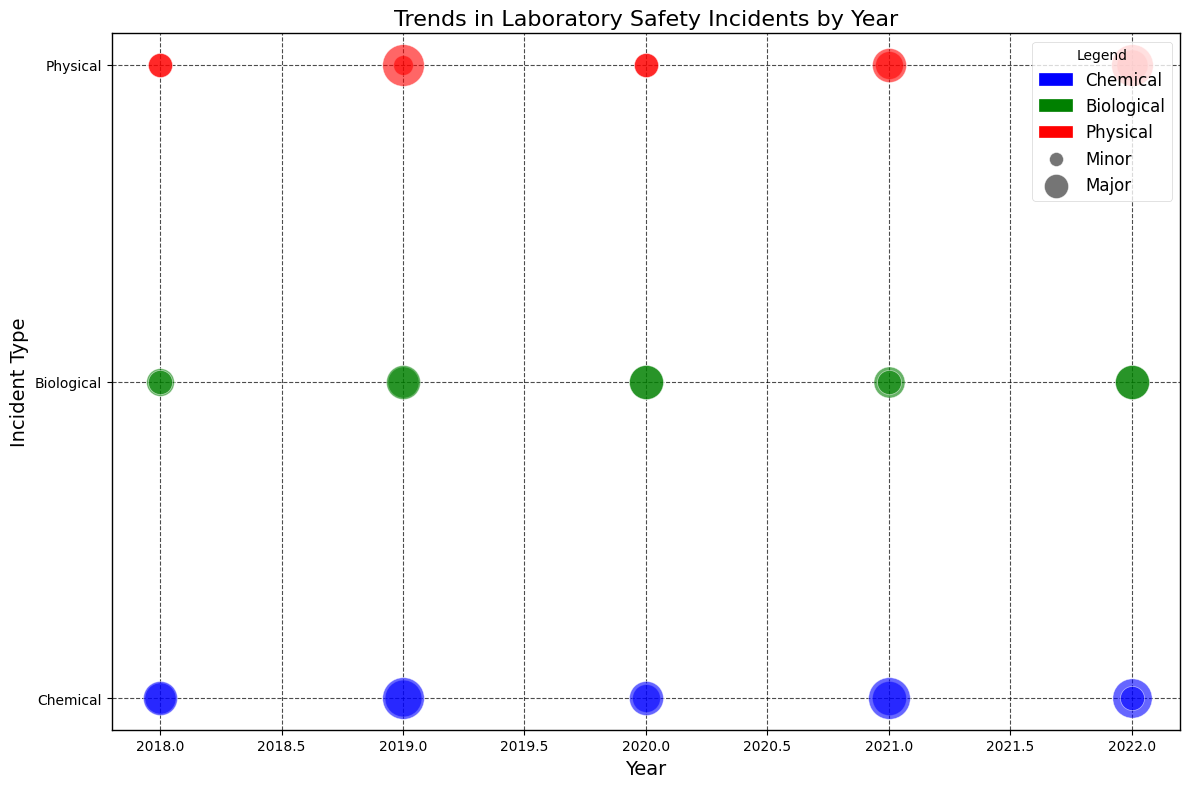What's the overall trend in the number of chemical incidents from 2018 to 2022? Observe the bubble sizes for Chemical incidents over the years. The counts show an increasing trend with minor fluctuations, rising from 7 in 2018, peaking at 9 in 2022.
Answer: Increasing Which year had the highest number of major physical incidents? Look for the largest bubbles labeled as Major under Physical incidents. The largest appears in 2019 and 2022, both with a count of 3.
Answer: 2019 and 2022 How did the number of biological minor incidents change from 2018 to 2022? Compare the bubble sizes for Biological Minor incidents across the years. It started with 4 in 2018, then increases to 5 in 2019, 6 in 2020, 5 in 2021, and 6 in 2022.
Answer: Increased then fluctuated Which incident type and severity was most common in 2022? Look for the largest bubble in 2022. The biggest bubble is Chemical Minor with a count of 8.
Answer: Chemical Minor Was there any year with more major incidents than minor incidents for Biological types? Compare the sizes of bubbles for Major and Minor Biological incidents for each year. No year stands out where Major incidents are more than Minor incidents.
Answer: No What was the total number of incidents (both minor and major) in 2020? Sum up all the bubble sizes for 2020: (4+2) for Chemical, (6+2) for Biological, and (3+1) for Physical. This totals to 18 incidents.
Answer: 18 Is there any trend in physical minor incidents from 2018 to 2022? Observe the sizes of Physical Minor incident bubbles from 2018 to 2022: 3 in 2018, 2 in 2019, 3 in 2020, 4 in 2021, and 5 in 2022. The trend is generally increasing.
Answer: Increasing How does the frequency of biological major incidents in 2021 compare to 2018? Compare the bubble size for Biological Major incidents in 2018 (1) and 2021 (1). Both years have the same size bubble.
Answer: Same Which incident type and severity decreased from 2019 to 2020? Compare bubble sizes for each type and severity from 2019 to 2020. Physical Minor incidents decreased from 2 to 1.
Answer: Physical Major What is the average number of major incidents for chemical types from 2018 to 2022? Add the counts of major Chemical incidents for each year (2+3+2+3+1 = 11) and divide by the number of years (5). Average = 11/5 = 2.2.
Answer: 2.2 